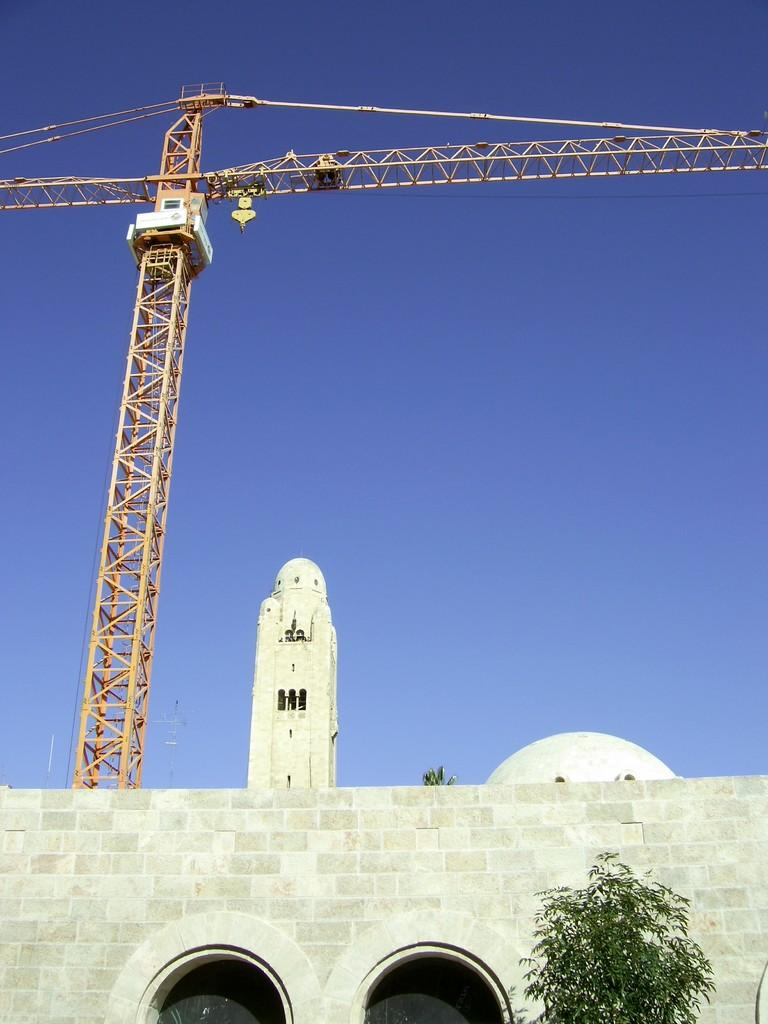What type of machinery can be seen in the image? There is a building crane in the image. What type of structure is present in the image? There is a stone building in the image. What type of plant is visible in the image? There is a tree in the image. What type of construction is being done in the image? There is an arch construction in the image. What color is the sky in the image? The sky is blue in the image. How many brothers are standing next to the tree in the image? There is no mention of brothers in the image, so we cannot answer that question. What type of powder is being used to construct the arch in the image? There is no mention of powder being used in the image, so we cannot answer that question. 